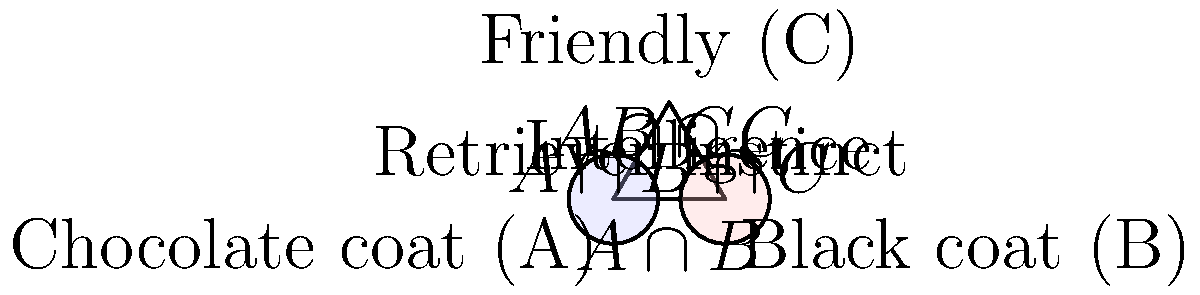In the Venn diagram above, traits from different Labrador bloodlines are represented. Group A represents Labs with a chocolate coat, group B represents Labs with a black coat, and group C represents friendly Labs. The intersection of A and B includes Labs with retriever instinct, while the intersection of all three groups (A ∩ B ∩ C) represents intelligent Labs.

If we consider the direct product of groups A and B (A × B), what would this represent in terms of Labrador traits, and how many distinct combinations of traits are possible in this product? To answer this question, let's break it down step-by-step:

1) The direct product of two groups A and B, denoted as A × B, is the set of all ordered pairs (a, b) where a ∈ A and b ∈ B.

2) In this context:
   - Group A represents Labs with a chocolate coat
   - Group B represents Labs with a black coat

3) The direct product A × B would represent all possible combinations of coat color (chocolate or black) with the presence or absence of retriever instinct.

4) To determine the number of distinct combinations, we need to consider the possible outcomes for each group:
   - For group A (chocolate coat): a Lab can either have or not have this trait (2 possibilities)
   - For group B (black coat): a Lab can either have or not have this trait (2 possibilities)

5) The total number of combinations in the direct product is the product of the number of possibilities for each group:
   $2 \times 2 = 4$

6) These four combinations are:
   (Chocolate, Not Black)
   (Chocolate, Black)
   (Not Chocolate, Black)
   (Not Chocolate, Not Black)

7) Note that (Chocolate, Black) and (Not Chocolate, Not Black) are not biologically possible for a single Lab, but they are still part of the mathematical direct product.

8) The retriever instinct, represented by the intersection of A and B, would be present in Labs that have either coat color, adding an additional layer of information to each combination.
Answer: 4 combinations of coat color and retriever instinct 